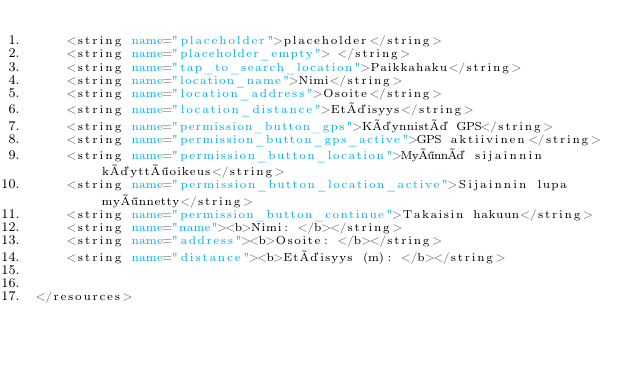<code> <loc_0><loc_0><loc_500><loc_500><_XML_>    <string name="placeholder">placeholder</string>
    <string name="placeholder_empty"> </string>
    <string name="tap_to_search_location">Paikkahaku</string>
    <string name="location_name">Nimi</string>
    <string name="location_address">Osoite</string>
    <string name="location_distance">Etäisyys</string>
    <string name="permission_button_gps">Käynnistä GPS</string>
    <string name="permission_button_gps_active">GPS aktiivinen</string>
    <string name="permission_button_location">Myönnä sijainnin käyttöoikeus</string>
    <string name="permission_button_location_active">Sijainnin lupa myönnetty</string>
    <string name="permission_button_continue">Takaisin hakuun</string>
    <string name="name"><b>Nimi: </b></string>
    <string name="address"><b>Osoite: </b></string>
    <string name="distance"><b>Etäisyys (m): </b></string>


</resources></code> 